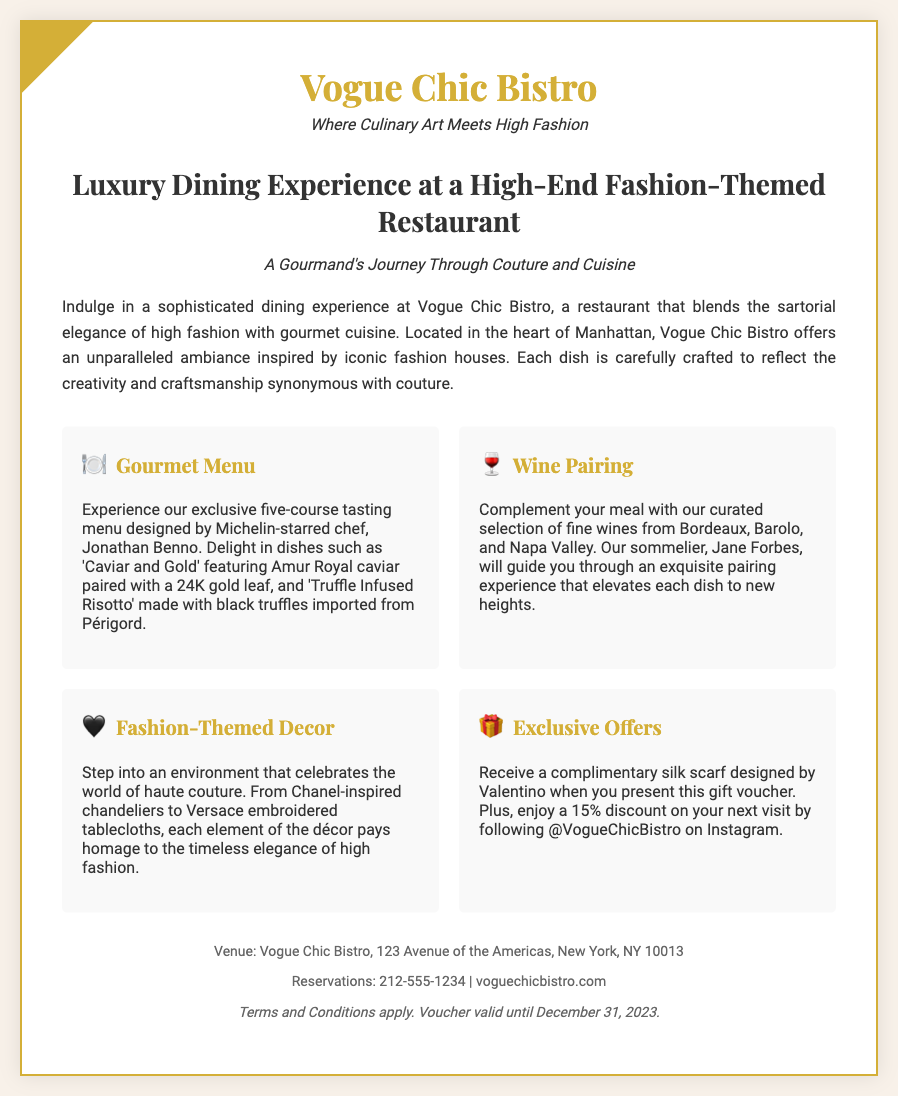what is the name of the restaurant? The name of the restaurant is prominently displayed at the top of the document.
Answer: Vogue Chic Bistro who is the chef mentioned in the document? The chef is noted in the gourmet menu section as the designer of the exclusive five-course tasting menu.
Answer: Jonathan Benno what type of cuisine does Vogue Chic Bistro offer? The cuisine is described in the document as gourmet cuisine that blends with high fashion.
Answer: gourmet cuisine what complimentary item is offered with the gift voucher? The document specifies an exclusive offer when presenting the voucher.
Answer: silk scarf what discount is available for the next visit? The document outlines a special incentive for guests who follow on social media.
Answer: 15% where is Vogue Chic Bistro located? The address is provided in the footer section of the document.
Answer: 123 Avenue of the Americas, New York, NY 10013 who is the sommelier named in the document? The sommelier is mentioned in the context of wine pairing with the meal.
Answer: Jane Forbes what is the validity date of the voucher? The document specifies when the voucher will no longer be valid.
Answer: December 31, 2023 